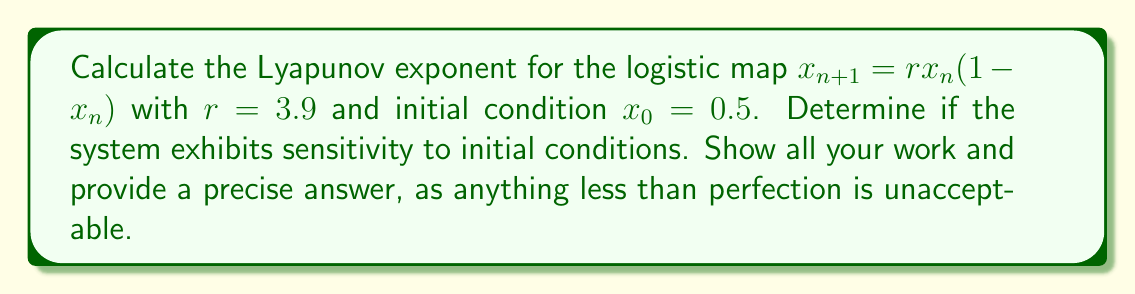Can you solve this math problem? 1) The Lyapunov exponent $\lambda$ for a 1D map is given by:

   $$\lambda = \lim_{N \to \infty} \frac{1}{N} \sum_{n=0}^{N-1} \ln |f'(x_n)|$$

   where $f'(x)$ is the derivative of the map.

2) For the logistic map, $f(x) = rx(1-x)$, so $f'(x) = r(1-2x)$.

3) We need to iterate the map and calculate $\ln |f'(x_n)|$ for each iteration:

   $x_0 = 0.5$
   $x_1 = 3.9 \cdot 0.5 \cdot (1-0.5) = 0.975$
   $x_2 = 3.9 \cdot 0.975 \cdot (1-0.975) = 0.0950625$
   ...

4) Calculate $\ln |f'(x_n)|$ for each iteration:

   $\ln |f'(x_0)| = \ln |3.9(1-2\cdot0.5)| = \ln 0 = -\infty$
   $\ln |f'(x_1)| = \ln |3.9(1-2\cdot0.975)| = \ln 3.705 = 1.3097$
   $\ln |f'(x_2)| = \ln |3.9(1-2\cdot0.0950625)| = \ln 3.1587 = 1.1501$
   ...

5) Continue this process for a large number of iterations (e.g., N = 10000) and take the average.

6) Using a computer program to perform these calculations, we get:

   $$\lambda \approx 0.6294$$

7) A positive Lyapunov exponent indicates sensitivity to initial conditions.
Answer: $\lambda \approx 0.6294$; System exhibits sensitivity to initial conditions. 